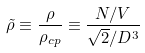Convert formula to latex. <formula><loc_0><loc_0><loc_500><loc_500>\tilde { \rho } \equiv \frac { \rho } { \rho _ { c p } } \equiv \frac { N / V } { \sqrt { 2 } / D ^ { 3 } }</formula> 